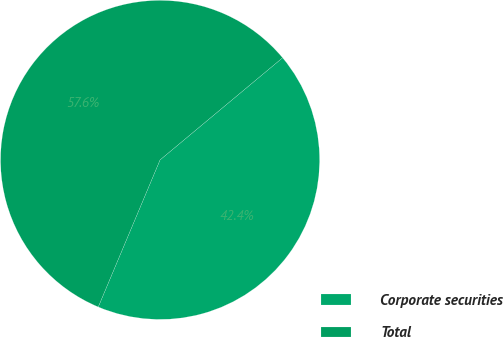<chart> <loc_0><loc_0><loc_500><loc_500><pie_chart><fcel>Corporate securities<fcel>Total<nl><fcel>42.39%<fcel>57.61%<nl></chart> 